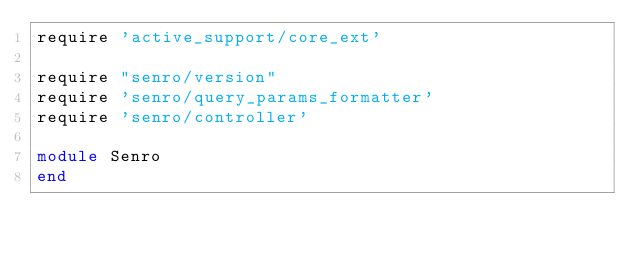Convert code to text. <code><loc_0><loc_0><loc_500><loc_500><_Ruby_>require 'active_support/core_ext'

require "senro/version"
require 'senro/query_params_formatter'
require 'senro/controller'

module Senro
end
</code> 